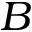<formula> <loc_0><loc_0><loc_500><loc_500>B</formula> 